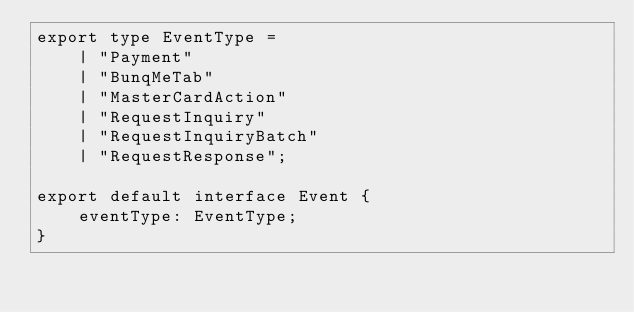<code> <loc_0><loc_0><loc_500><loc_500><_TypeScript_>export type EventType =
    | "Payment"
    | "BunqMeTab"
    | "MasterCardAction"
    | "RequestInquiry"
    | "RequestInquiryBatch"
    | "RequestResponse";

export default interface Event {
    eventType: EventType;
}
</code> 